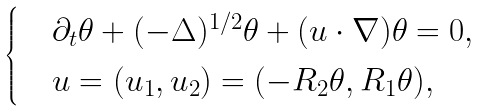<formula> <loc_0><loc_0><loc_500><loc_500>\begin{cases} & \partial _ { t } \theta + ( - \Delta ) ^ { 1 / 2 } \theta + ( u \cdot \nabla ) \theta = 0 , \\ & u = ( u _ { 1 } , u _ { 2 } ) = ( - R _ { 2 } \theta , R _ { 1 } \theta ) , \end{cases}</formula> 